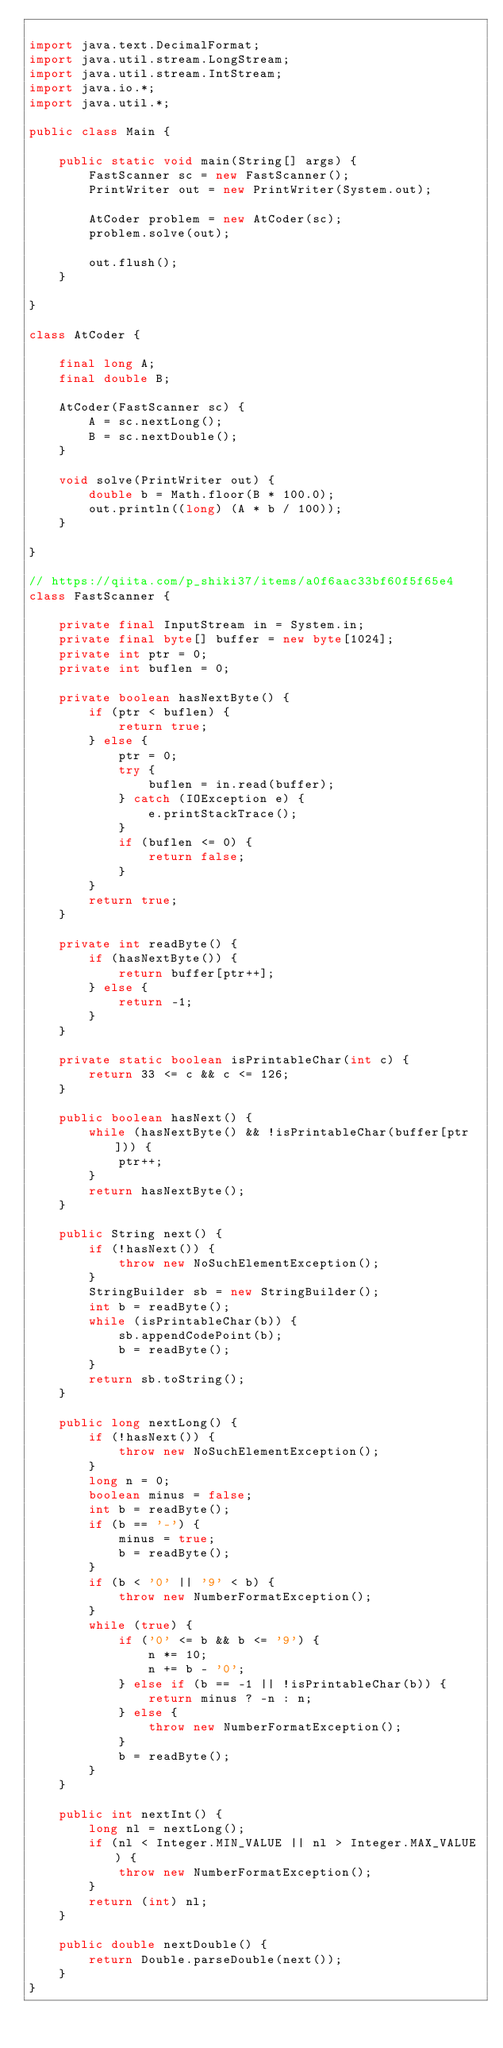Convert code to text. <code><loc_0><loc_0><loc_500><loc_500><_Java_>
import java.text.DecimalFormat;
import java.util.stream.LongStream;
import java.util.stream.IntStream;
import java.io.*;
import java.util.*;

public class Main {

    public static void main(String[] args) {
        FastScanner sc = new FastScanner();
        PrintWriter out = new PrintWriter(System.out);

        AtCoder problem = new AtCoder(sc);
        problem.solve(out);

        out.flush();
    }

}

class AtCoder {

    final long A;
    final double B;

    AtCoder(FastScanner sc) {
        A = sc.nextLong();
        B = sc.nextDouble();
    }

    void solve(PrintWriter out) {
        double b = Math.floor(B * 100.0);
        out.println((long) (A * b / 100));
    }

}

// https://qiita.com/p_shiki37/items/a0f6aac33bf60f5f65e4
class FastScanner {

    private final InputStream in = System.in;
    private final byte[] buffer = new byte[1024];
    private int ptr = 0;
    private int buflen = 0;

    private boolean hasNextByte() {
        if (ptr < buflen) {
            return true;
        } else {
            ptr = 0;
            try {
                buflen = in.read(buffer);
            } catch (IOException e) {
                e.printStackTrace();
            }
            if (buflen <= 0) {
                return false;
            }
        }
        return true;
    }

    private int readByte() {
        if (hasNextByte()) {
            return buffer[ptr++];
        } else {
            return -1;
        }
    }

    private static boolean isPrintableChar(int c) {
        return 33 <= c && c <= 126;
    }

    public boolean hasNext() {
        while (hasNextByte() && !isPrintableChar(buffer[ptr])) {
            ptr++;
        }
        return hasNextByte();
    }

    public String next() {
        if (!hasNext()) {
            throw new NoSuchElementException();
        }
        StringBuilder sb = new StringBuilder();
        int b = readByte();
        while (isPrintableChar(b)) {
            sb.appendCodePoint(b);
            b = readByte();
        }
        return sb.toString();
    }

    public long nextLong() {
        if (!hasNext()) {
            throw new NoSuchElementException();
        }
        long n = 0;
        boolean minus = false;
        int b = readByte();
        if (b == '-') {
            minus = true;
            b = readByte();
        }
        if (b < '0' || '9' < b) {
            throw new NumberFormatException();
        }
        while (true) {
            if ('0' <= b && b <= '9') {
                n *= 10;
                n += b - '0';
            } else if (b == -1 || !isPrintableChar(b)) {
                return minus ? -n : n;
            } else {
                throw new NumberFormatException();
            }
            b = readByte();
        }
    }

    public int nextInt() {
        long nl = nextLong();
        if (nl < Integer.MIN_VALUE || nl > Integer.MAX_VALUE) {
            throw new NumberFormatException();
        }
        return (int) nl;
    }

    public double nextDouble() {
        return Double.parseDouble(next());
    }
}
</code> 